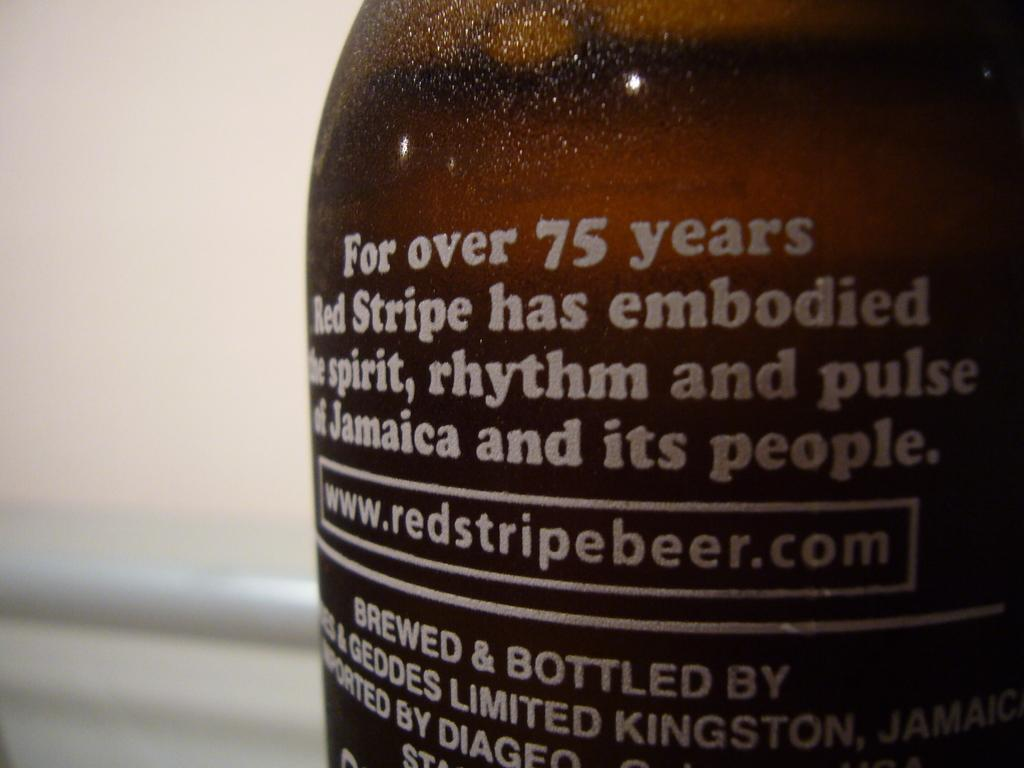<image>
Create a compact narrative representing the image presented. A bottle of Red Strip has a description of the product in white lettering. 